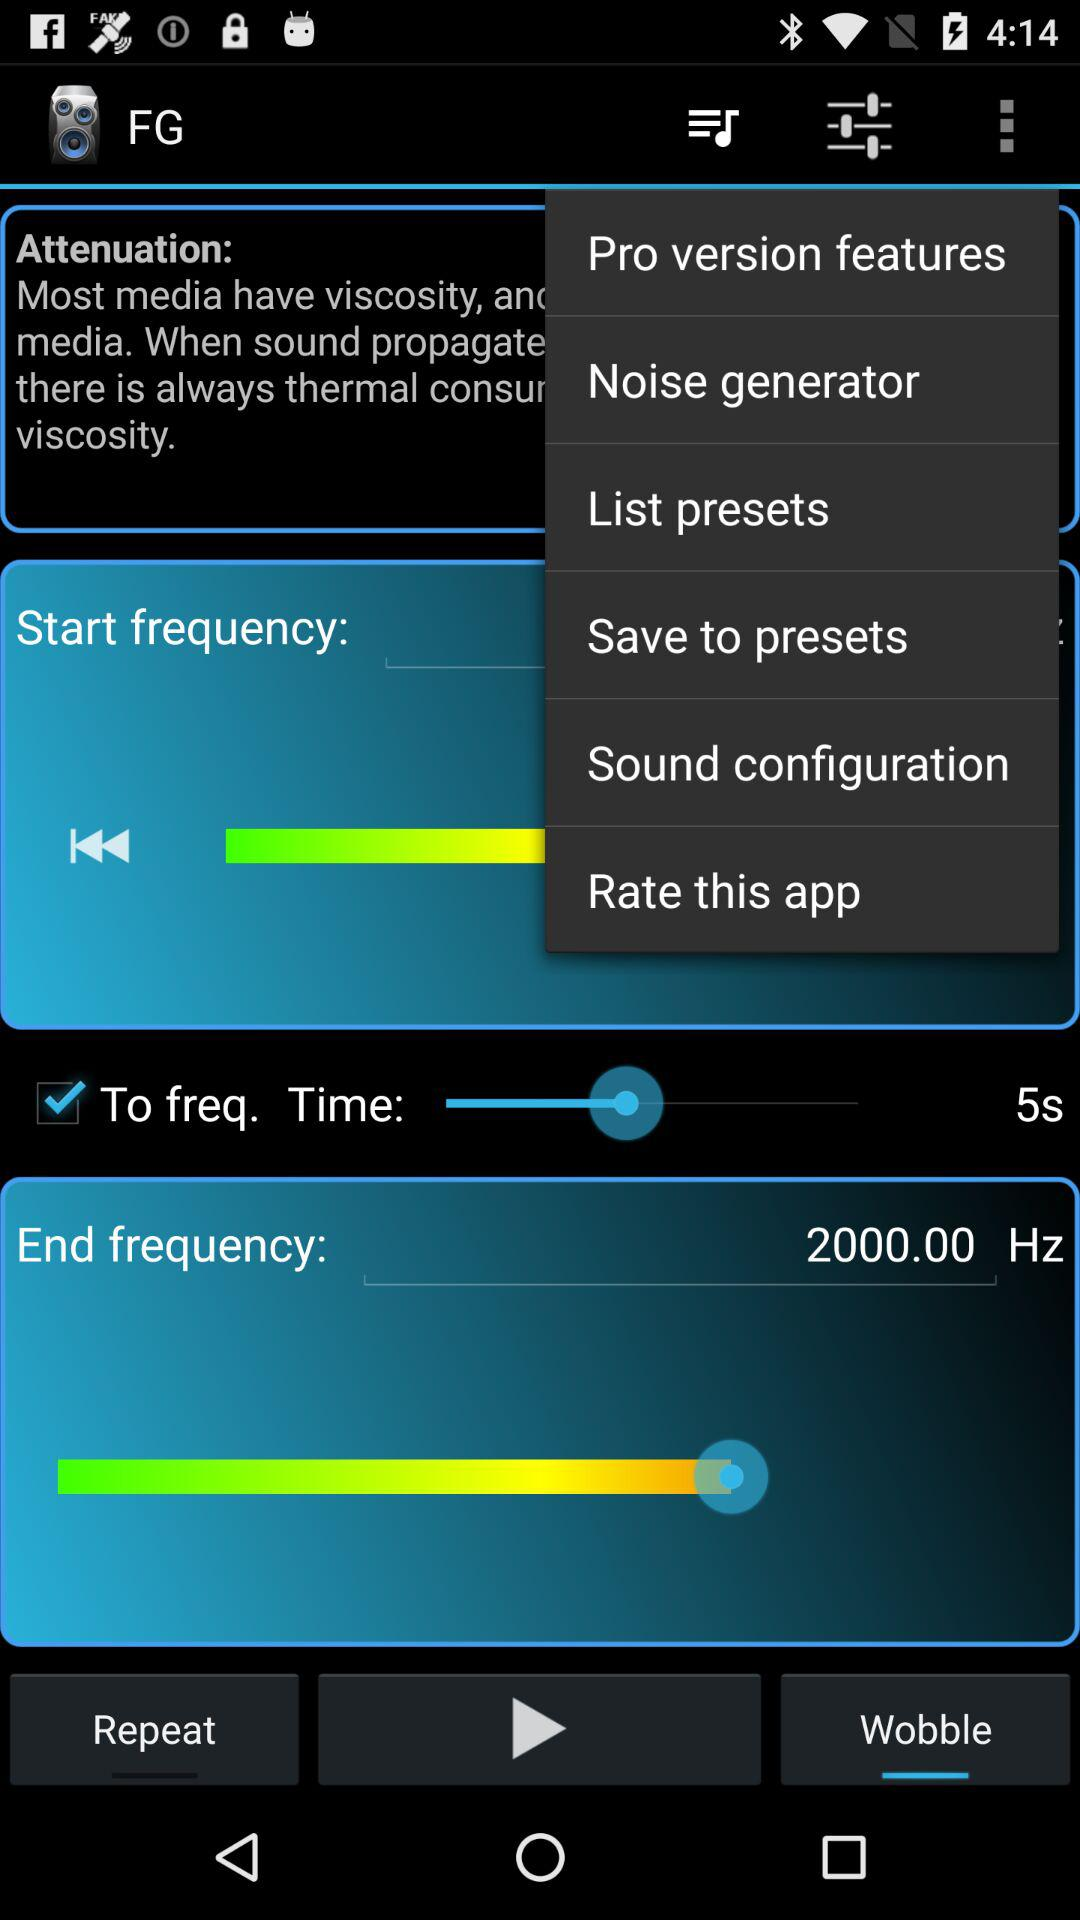What is the time set? The time set is 5s. 